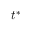Convert formula to latex. <formula><loc_0><loc_0><loc_500><loc_500>{ { t } ^ { * } }</formula> 